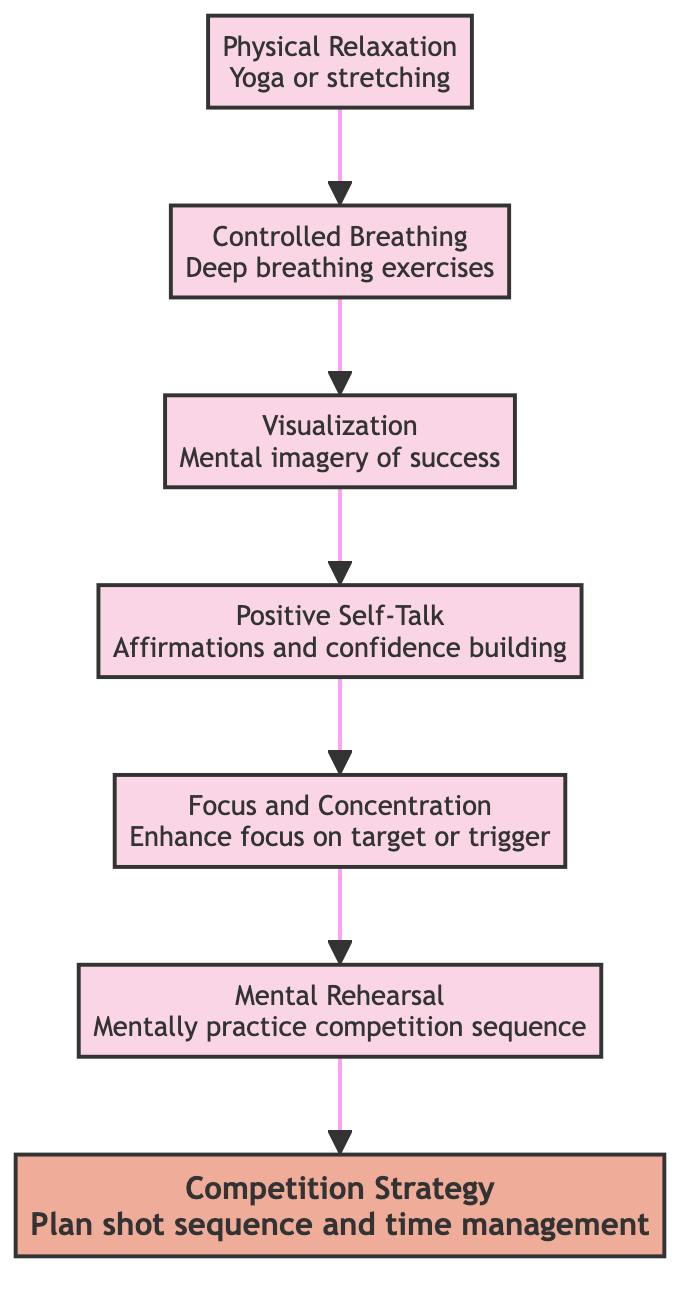What is the initial stage in the flow chart? The diagram outlines various mental preparation techniques for airgun shooting, starting with "Physical Relaxation" at the bottom.
Answer: Physical Relaxation Which stage comes after "Controlled Breathing"? By following the flow of the chart, "Controlled Breathing" is followed by "Visualization."
Answer: Visualization How many total stages are there in the flow chart? Counting each distinct stage from bottom to top, there are seven stages in total.
Answer: 7 What is the last stage in this bottom-to-top flow chart? The final stage, at the top of the diagram, is "Competition Strategy."
Answer: Competition Strategy Which two stages focus on building mental confidence? The stages "Positive Self-Talk" and "Mental Rehearsal" are both aimed at enhancing mental confidence.
Answer: Positive Self-Talk and Mental Rehearsal What technique is suggested before "Focus and Concentration"? "Visualization" is the technique that precedes "Focus and Concentration" in the flow chart.
Answer: Visualization What stage would you reach by applying Controlled Breathing? "Controlled Breathing" leads to the subsequent stage "Visualization" in the sequence.
Answer: Visualization Is "Competition Strategy" a foundational technique in the flow chart? "Competition Strategy" is at the top, indicating it is not foundational but rather a culmination of all previous techniques.
Answer: No In which two stages do you practice exercises that involve sequencing? "Mental Rehearsal" and "Competition Strategy" both involve planning or practicing in a sequential manner.
Answer: Mental Rehearsal and Competition Strategy 